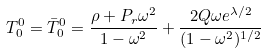<formula> <loc_0><loc_0><loc_500><loc_500>T ^ { 0 } _ { 0 } = \bar { T } ^ { 0 } _ { 0 } = \frac { \rho + P _ { r } \omega ^ { 2 } } { 1 - \omega ^ { 2 } } + \frac { 2 Q \omega e ^ { \lambda / 2 } } { ( 1 - \omega ^ { 2 } ) ^ { 1 / 2 } }</formula> 